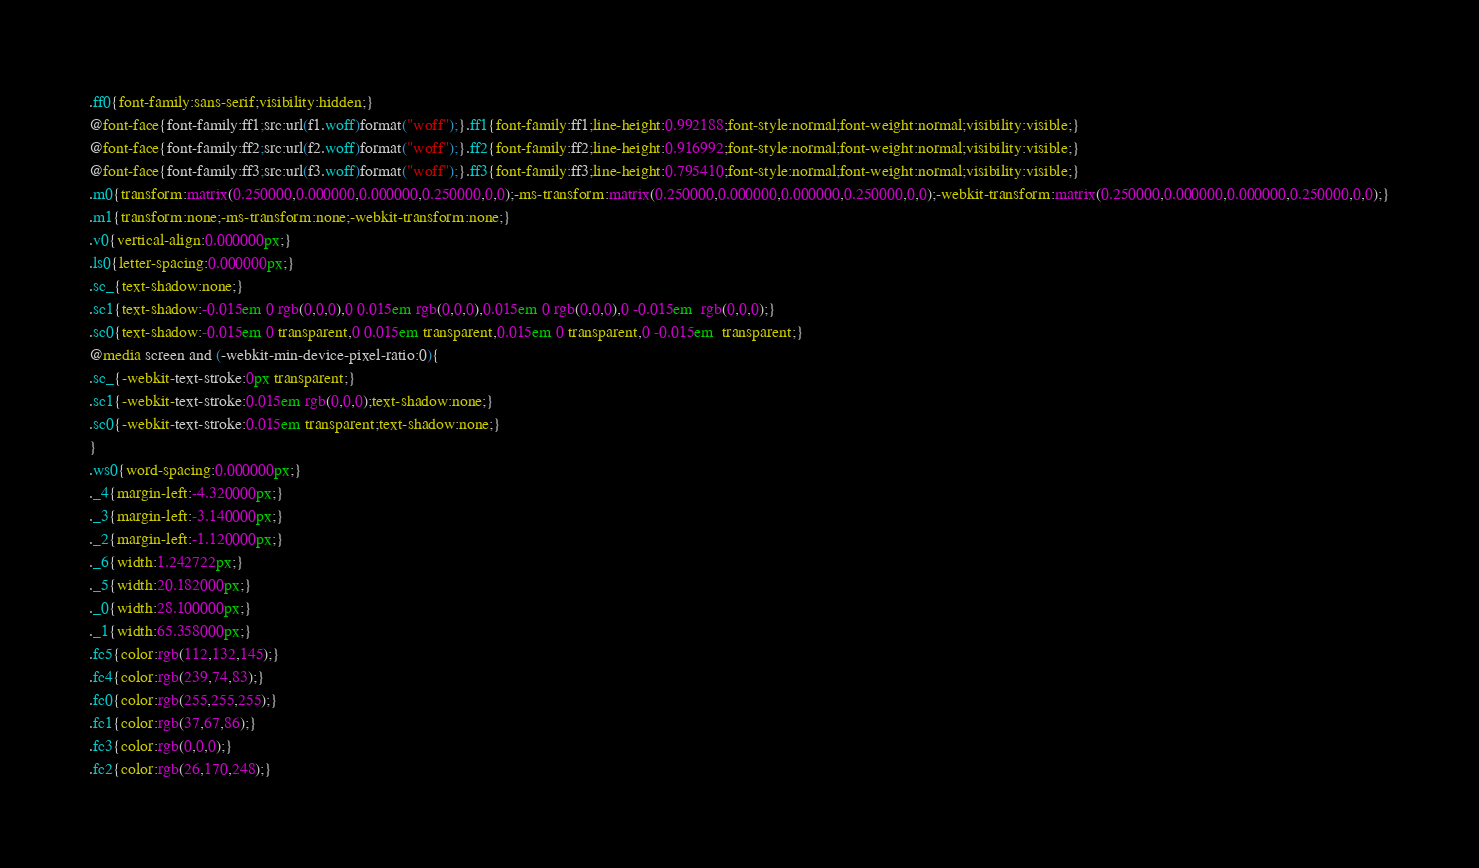<code> <loc_0><loc_0><loc_500><loc_500><_CSS_>.ff0{font-family:sans-serif;visibility:hidden;}
@font-face{font-family:ff1;src:url(f1.woff)format("woff");}.ff1{font-family:ff1;line-height:0.992188;font-style:normal;font-weight:normal;visibility:visible;}
@font-face{font-family:ff2;src:url(f2.woff)format("woff");}.ff2{font-family:ff2;line-height:0.916992;font-style:normal;font-weight:normal;visibility:visible;}
@font-face{font-family:ff3;src:url(f3.woff)format("woff");}.ff3{font-family:ff3;line-height:0.795410;font-style:normal;font-weight:normal;visibility:visible;}
.m0{transform:matrix(0.250000,0.000000,0.000000,0.250000,0,0);-ms-transform:matrix(0.250000,0.000000,0.000000,0.250000,0,0);-webkit-transform:matrix(0.250000,0.000000,0.000000,0.250000,0,0);}
.m1{transform:none;-ms-transform:none;-webkit-transform:none;}
.v0{vertical-align:0.000000px;}
.ls0{letter-spacing:0.000000px;}
.sc_{text-shadow:none;}
.sc1{text-shadow:-0.015em 0 rgb(0,0,0),0 0.015em rgb(0,0,0),0.015em 0 rgb(0,0,0),0 -0.015em  rgb(0,0,0);}
.sc0{text-shadow:-0.015em 0 transparent,0 0.015em transparent,0.015em 0 transparent,0 -0.015em  transparent;}
@media screen and (-webkit-min-device-pixel-ratio:0){
.sc_{-webkit-text-stroke:0px transparent;}
.sc1{-webkit-text-stroke:0.015em rgb(0,0,0);text-shadow:none;}
.sc0{-webkit-text-stroke:0.015em transparent;text-shadow:none;}
}
.ws0{word-spacing:0.000000px;}
._4{margin-left:-4.320000px;}
._3{margin-left:-3.140000px;}
._2{margin-left:-1.120000px;}
._6{width:1.242722px;}
._5{width:20.182000px;}
._0{width:28.100000px;}
._1{width:65.358000px;}
.fc5{color:rgb(112,132,145);}
.fc4{color:rgb(239,74,83);}
.fc0{color:rgb(255,255,255);}
.fc1{color:rgb(37,67,86);}
.fc3{color:rgb(0,0,0);}
.fc2{color:rgb(26,170,248);}</code> 